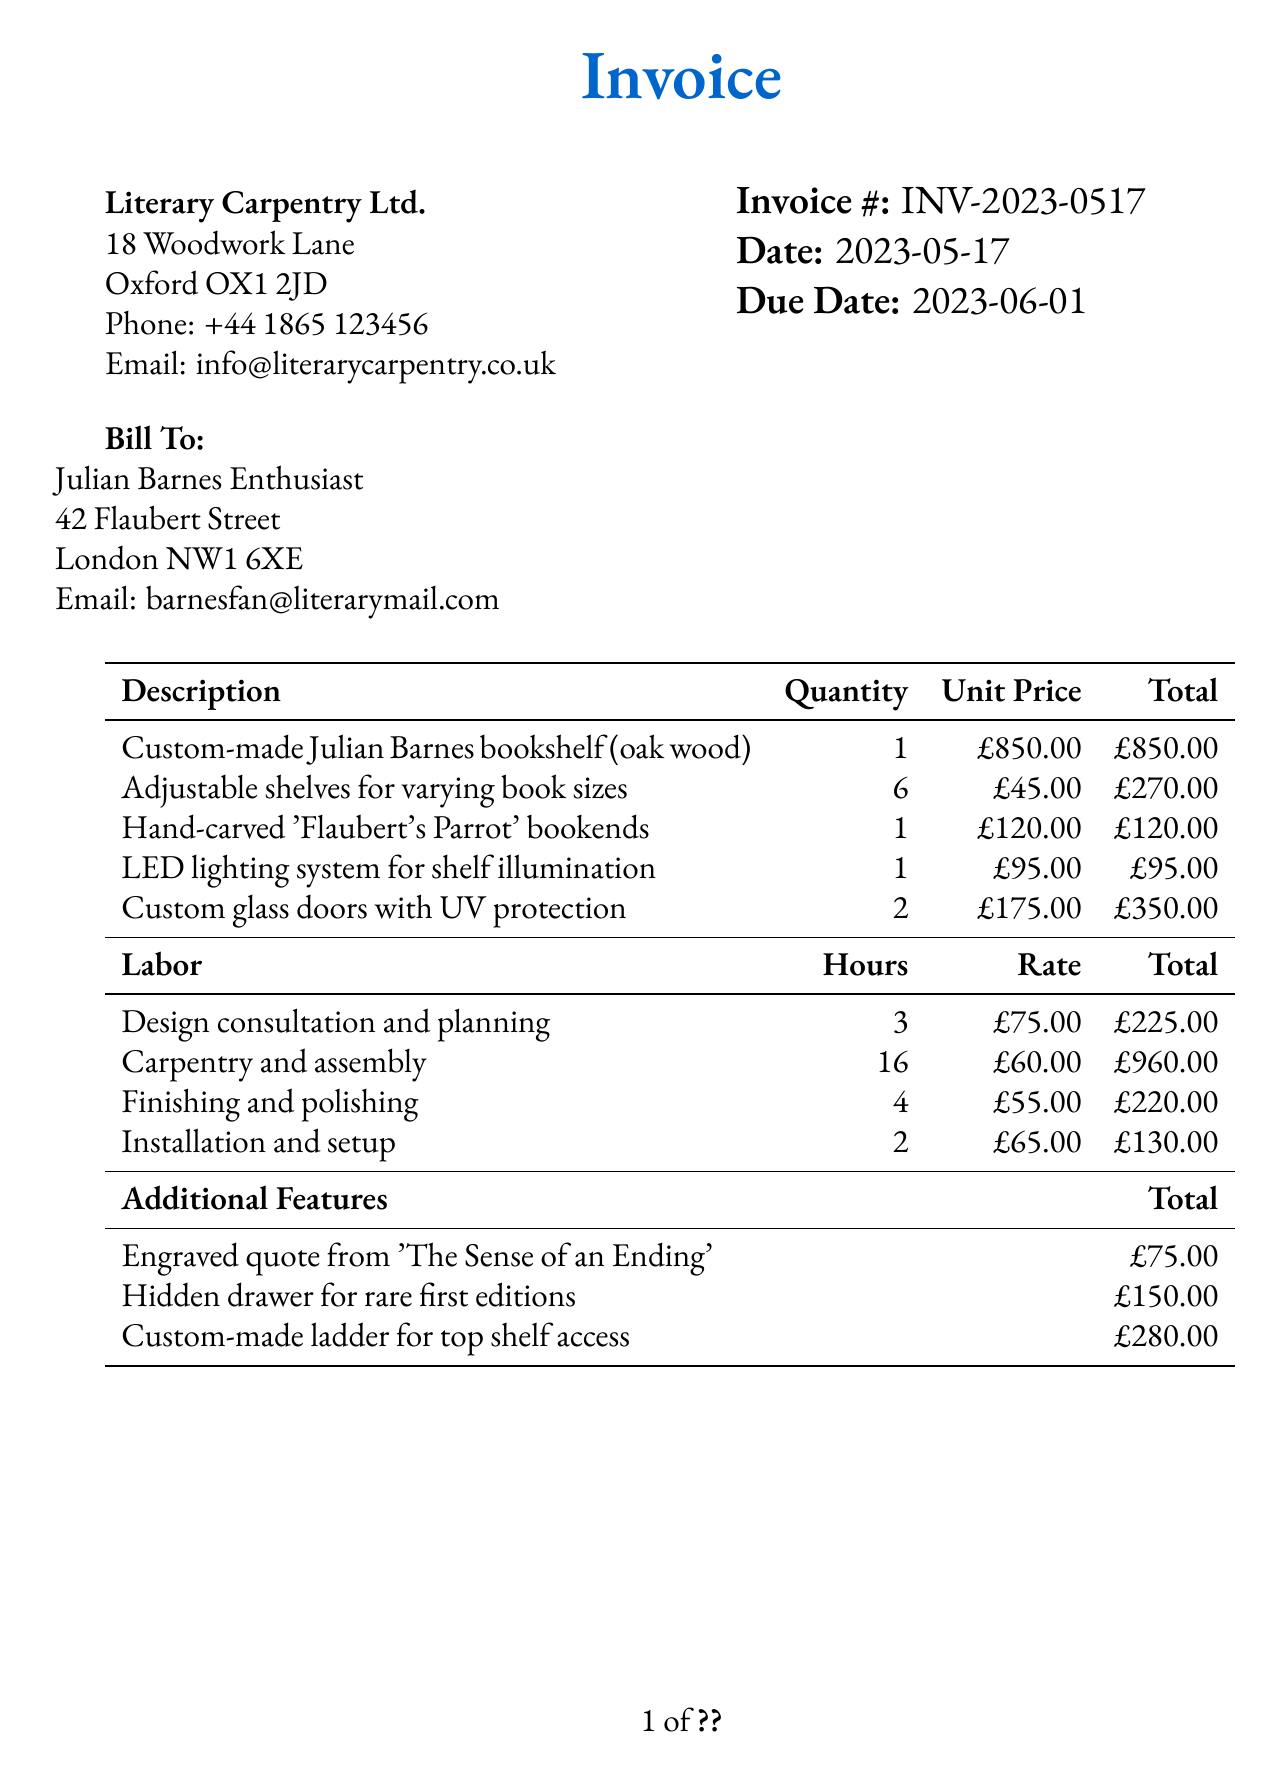What is the invoice number? The invoice number can be found at the top of the document, providing a unique identifier for this transaction.
Answer: INV-2023-0517 What is the due date for payment? The due date for payment is specified near the invoice date, indicating when payment is expected.
Answer: 2023-06-01 Who is the seller? The seller's information, including name and address, is provided in the document.
Answer: Literary Carpentry Ltd How many adjustable shelves are included? This quantity is detailed in the items section of the invoice, describing additional features of the bookshelf.
Answer: 6 What is the subtotal amount before VAT? The subtotal amount is listed separately from VAT, representing the total before taxes.
Answer: £3,725.00 What is the total cost of additional features? The total cost for additional features can be calculated by adding each item's cost in that section of the document.
Answer: £505.00 How many hours were spent on carpentry and assembly? The document specifies hours allocated to this specific labor task in the labor section.
Answer: 16 What is the VAT rate applied to this invoice? The VAT rate is indicated in the invoice and affects the total calculation.
Answer: 20% What payment terms are specified? The payment terms outline the conditions for payment within the document.
Answer: Payment due within 15 days 